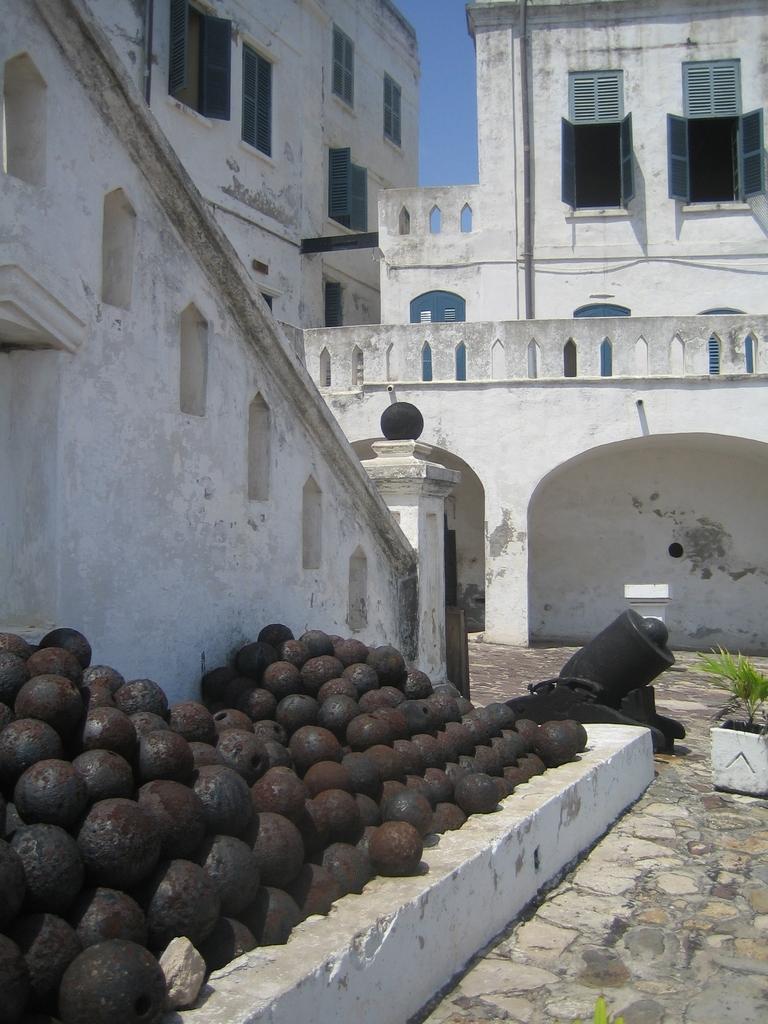Please provide a concise description of this image. This image is taken outdoors. At the bottom of the image there is a floor. On the left side of the image there are many bullets. On the right side of the image there is a plant in the pot. In the middle of the image there are two buildings with wall and windows and there is a cannon on the ground. 